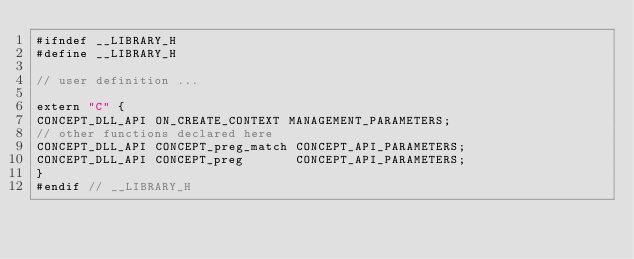<code> <loc_0><loc_0><loc_500><loc_500><_C_>#ifndef __LIBRARY_H
#define __LIBRARY_H

// user definition ...

extern "C" {
CONCEPT_DLL_API ON_CREATE_CONTEXT MANAGEMENT_PARAMETERS;
// other functions declared here
CONCEPT_DLL_API CONCEPT_preg_match CONCEPT_API_PARAMETERS;
CONCEPT_DLL_API CONCEPT_preg       CONCEPT_API_PARAMETERS;
}
#endif // __LIBRARY_H
</code> 